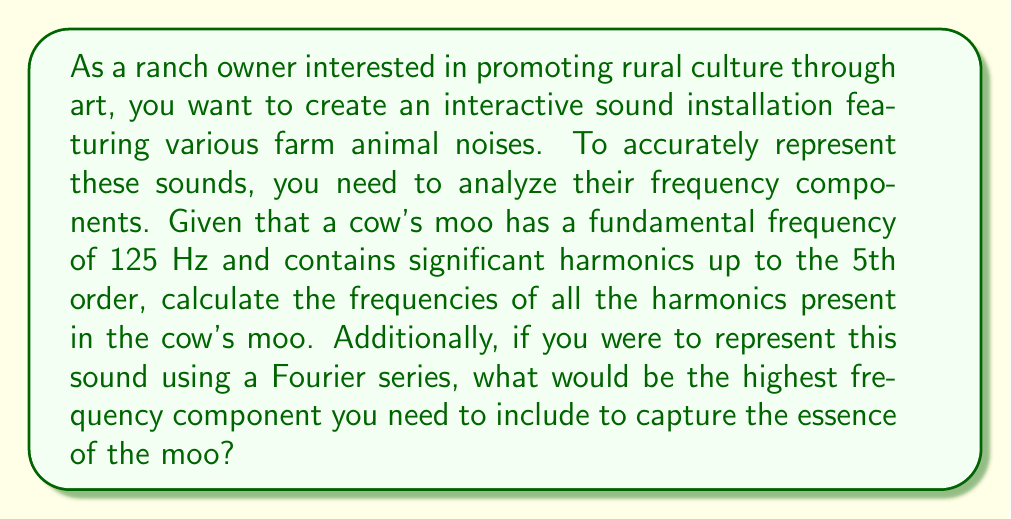Provide a solution to this math problem. To solve this problem, we need to understand harmonics and their relationship to the fundamental frequency:

1. Harmonics are integer multiples of the fundamental frequency.
2. The nth harmonic has a frequency of n * f0, where f0 is the fundamental frequency.

Given:
- Fundamental frequency (f0) = 125 Hz
- Significant harmonics up to the 5th order

Let's calculate the frequencies of all harmonics:

1st harmonic (fundamental): $f_1 = 1 \times 125 \text{ Hz} = 125 \text{ Hz}$
2nd harmonic: $f_2 = 2 \times 125 \text{ Hz} = 250 \text{ Hz}$
3rd harmonic: $f_3 = 3 \times 125 \text{ Hz} = 375 \text{ Hz}$
4th harmonic: $f_4 = 4 \times 125 \text{ Hz} = 500 \text{ Hz}$
5th harmonic: $f_5 = 5 \times 125 \text{ Hz} = 625 \text{ Hz}$

The highest frequency component in this case would be the 5th harmonic, as it is the highest order harmonic mentioned in the problem statement.

In a Fourier series representation, we would need to include all these harmonics to capture the essence of the cow's moo. The highest frequency component would thus be the 5th harmonic at 625 Hz.

The general form of a Fourier series for this sound could be represented as:

$$f(t) = A_0 + \sum_{n=1}^{5} A_n \cos(2\pi n f_0 t) + B_n \sin(2\pi n f_0 t)$$

Where:
- $A_0$ is the DC component
- $A_n$ and $B_n$ are the amplitudes of the cosine and sine terms for each harmonic
- $f_0$ is the fundamental frequency (125 Hz)
- $n$ is the harmonic number, ranging from 1 to 5
Answer: The frequencies of the harmonics present in the cow's moo are:
1st: 125 Hz, 2nd: 250 Hz, 3rd: 375 Hz, 4th: 500 Hz, 5th: 625 Hz

The highest frequency component needed in the Fourier series representation is 625 Hz (5th harmonic). 